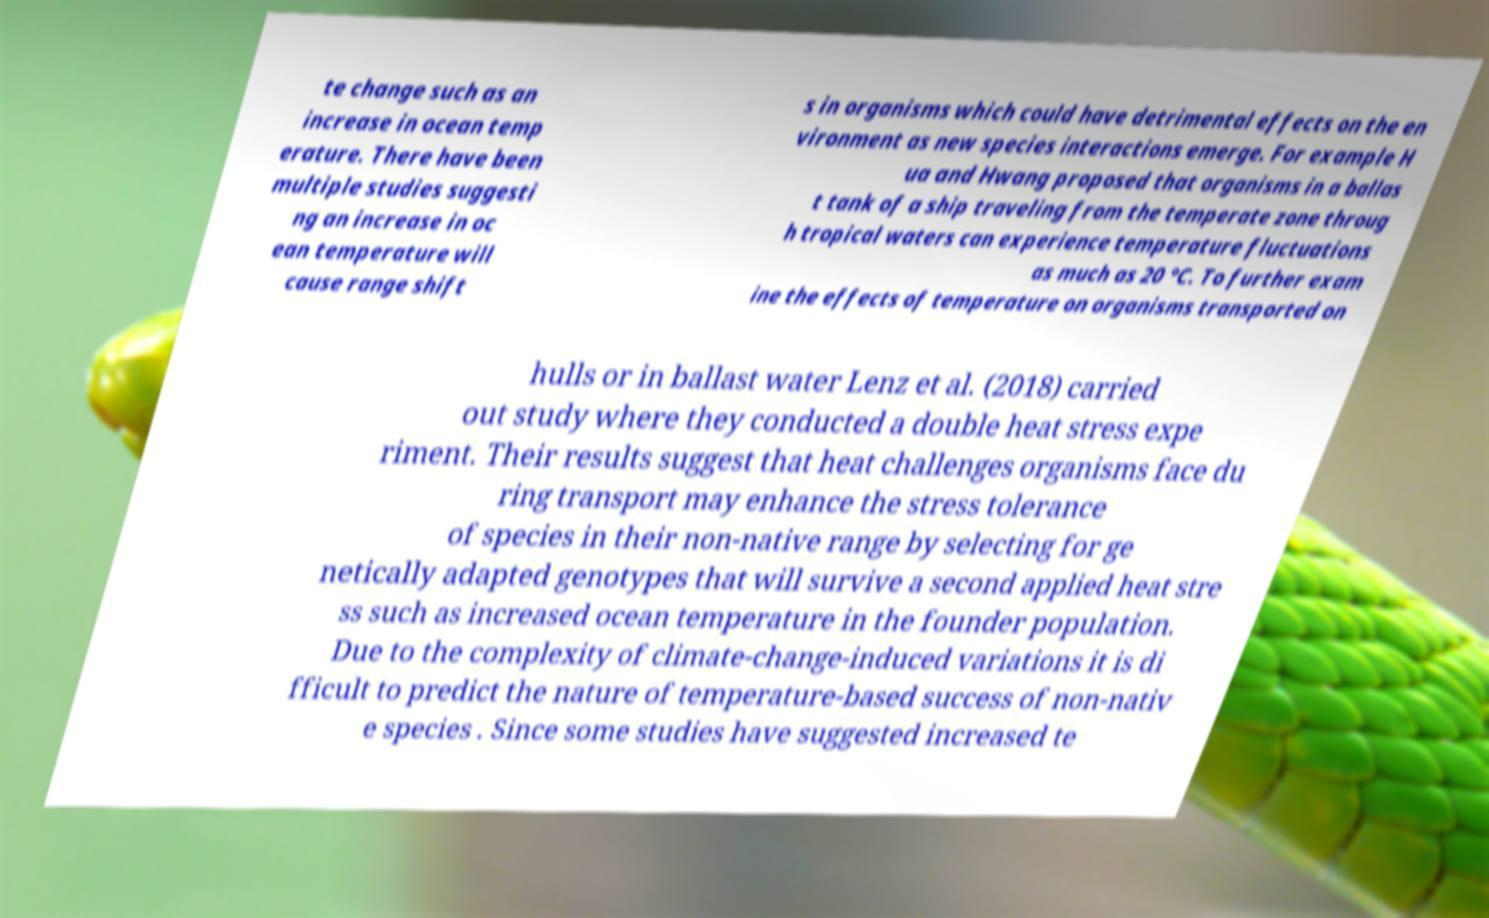There's text embedded in this image that I need extracted. Can you transcribe it verbatim? te change such as an increase in ocean temp erature. There have been multiple studies suggesti ng an increase in oc ean temperature will cause range shift s in organisms which could have detrimental effects on the en vironment as new species interactions emerge. For example H ua and Hwang proposed that organisms in a ballas t tank of a ship traveling from the temperate zone throug h tropical waters can experience temperature fluctuations as much as 20 °C. To further exam ine the effects of temperature on organisms transported on hulls or in ballast water Lenz et al. (2018) carried out study where they conducted a double heat stress expe riment. Their results suggest that heat challenges organisms face du ring transport may enhance the stress tolerance of species in their non-native range by selecting for ge netically adapted genotypes that will survive a second applied heat stre ss such as increased ocean temperature in the founder population. Due to the complexity of climate-change-induced variations it is di fficult to predict the nature of temperature-based success of non-nativ e species . Since some studies have suggested increased te 